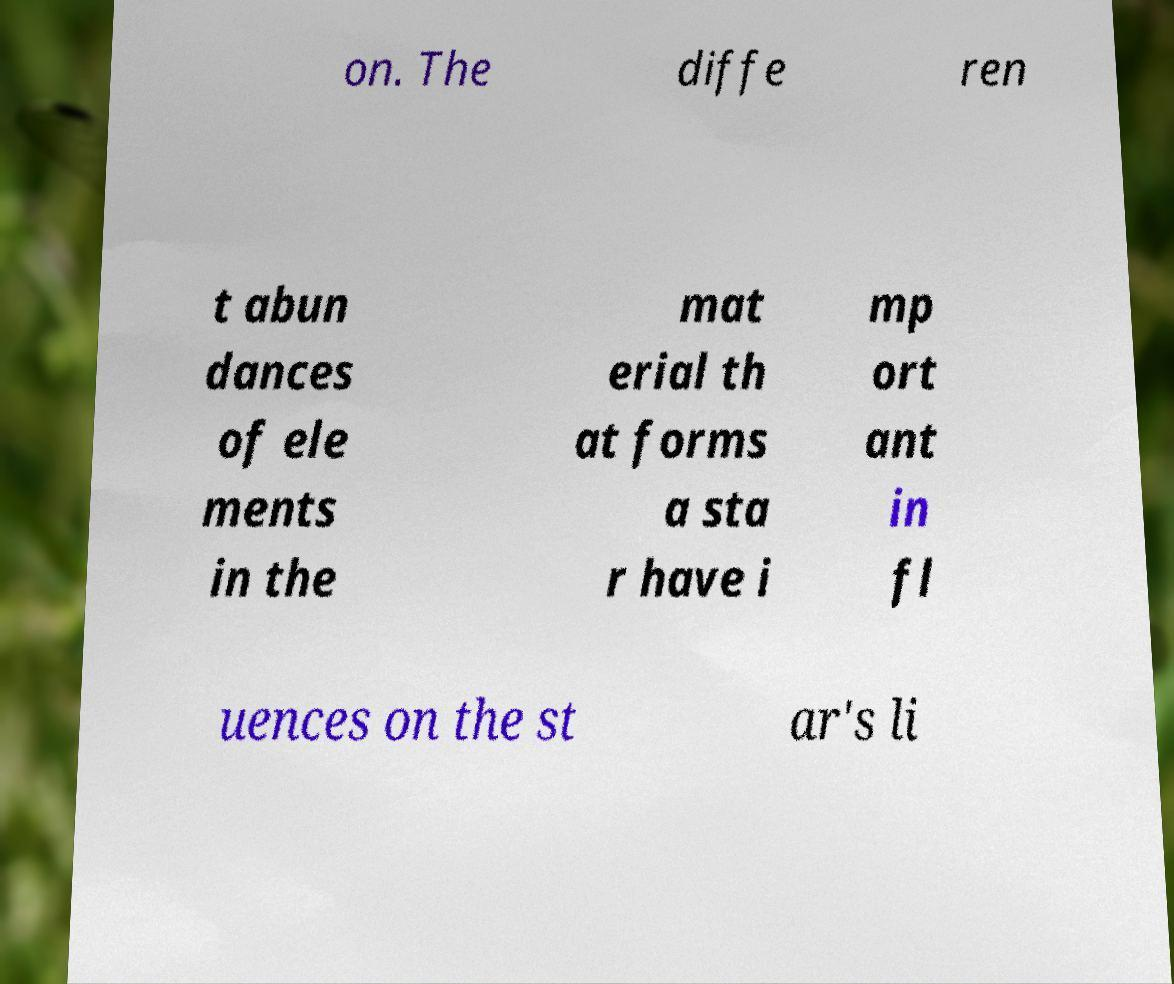I need the written content from this picture converted into text. Can you do that? on. The diffe ren t abun dances of ele ments in the mat erial th at forms a sta r have i mp ort ant in fl uences on the st ar's li 